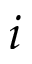<formula> <loc_0><loc_0><loc_500><loc_500>i</formula> 